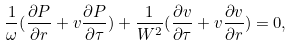<formula> <loc_0><loc_0><loc_500><loc_500>\frac { 1 } { \omega } ( \frac { \partial P } { \partial r } + v \frac { \partial P } { \partial \tau } ) + \frac { 1 } { W ^ { 2 } } ( \frac { \partial v } { \partial \tau } + v \frac { \partial v } { \partial r } ) = 0 ,</formula> 